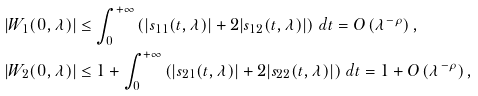<formula> <loc_0><loc_0><loc_500><loc_500>| W _ { 1 } ( 0 , \lambda ) | & \leq \int _ { 0 } ^ { + \infty } \left ( | s _ { 1 1 } ( t , \lambda ) | + 2 | s _ { 1 2 } ( t , \lambda ) | \right ) \, d t = O \left ( \lambda ^ { - \rho } \right ) , \\ | W _ { 2 } ( 0 , \lambda ) | & \leq 1 + \int _ { 0 } ^ { + \infty } \left ( | s _ { 2 1 } ( t , \lambda ) | + 2 | s _ { 2 2 } ( t , \lambda ) | \right ) \, d t = 1 + O \left ( \lambda ^ { - \rho } \right ) ,</formula> 